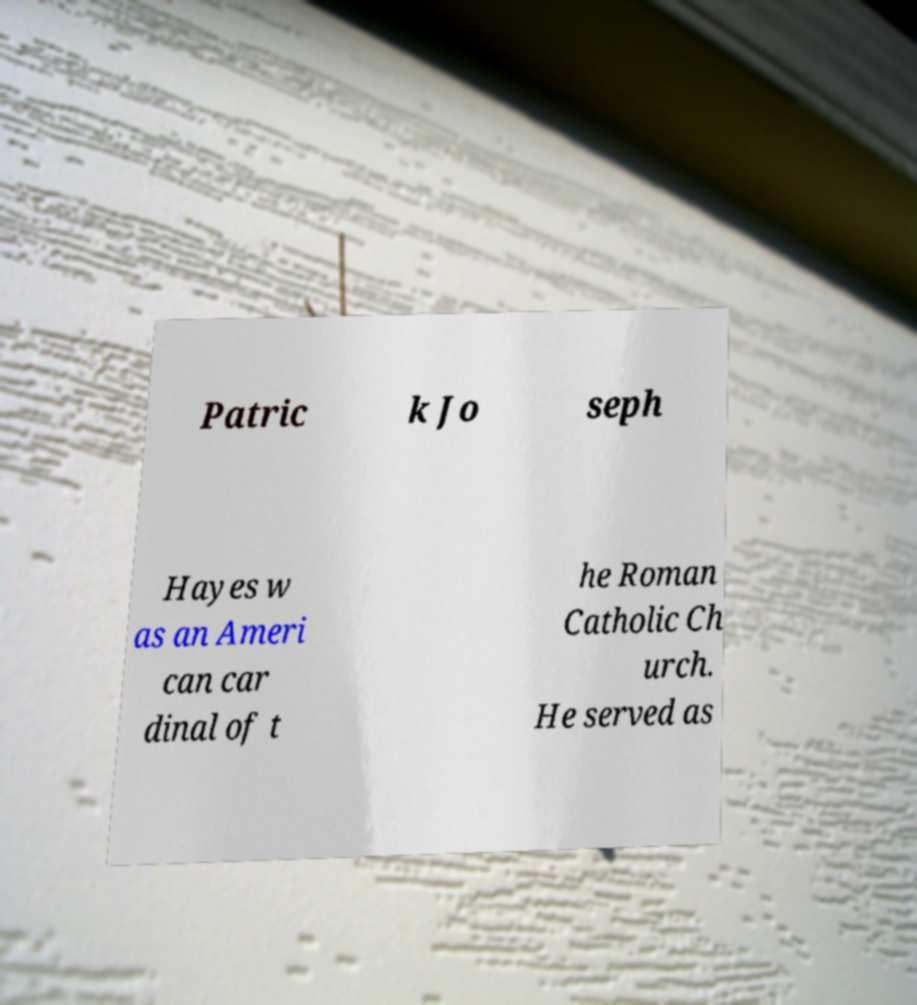Can you read and provide the text displayed in the image?This photo seems to have some interesting text. Can you extract and type it out for me? Patric k Jo seph Hayes w as an Ameri can car dinal of t he Roman Catholic Ch urch. He served as 